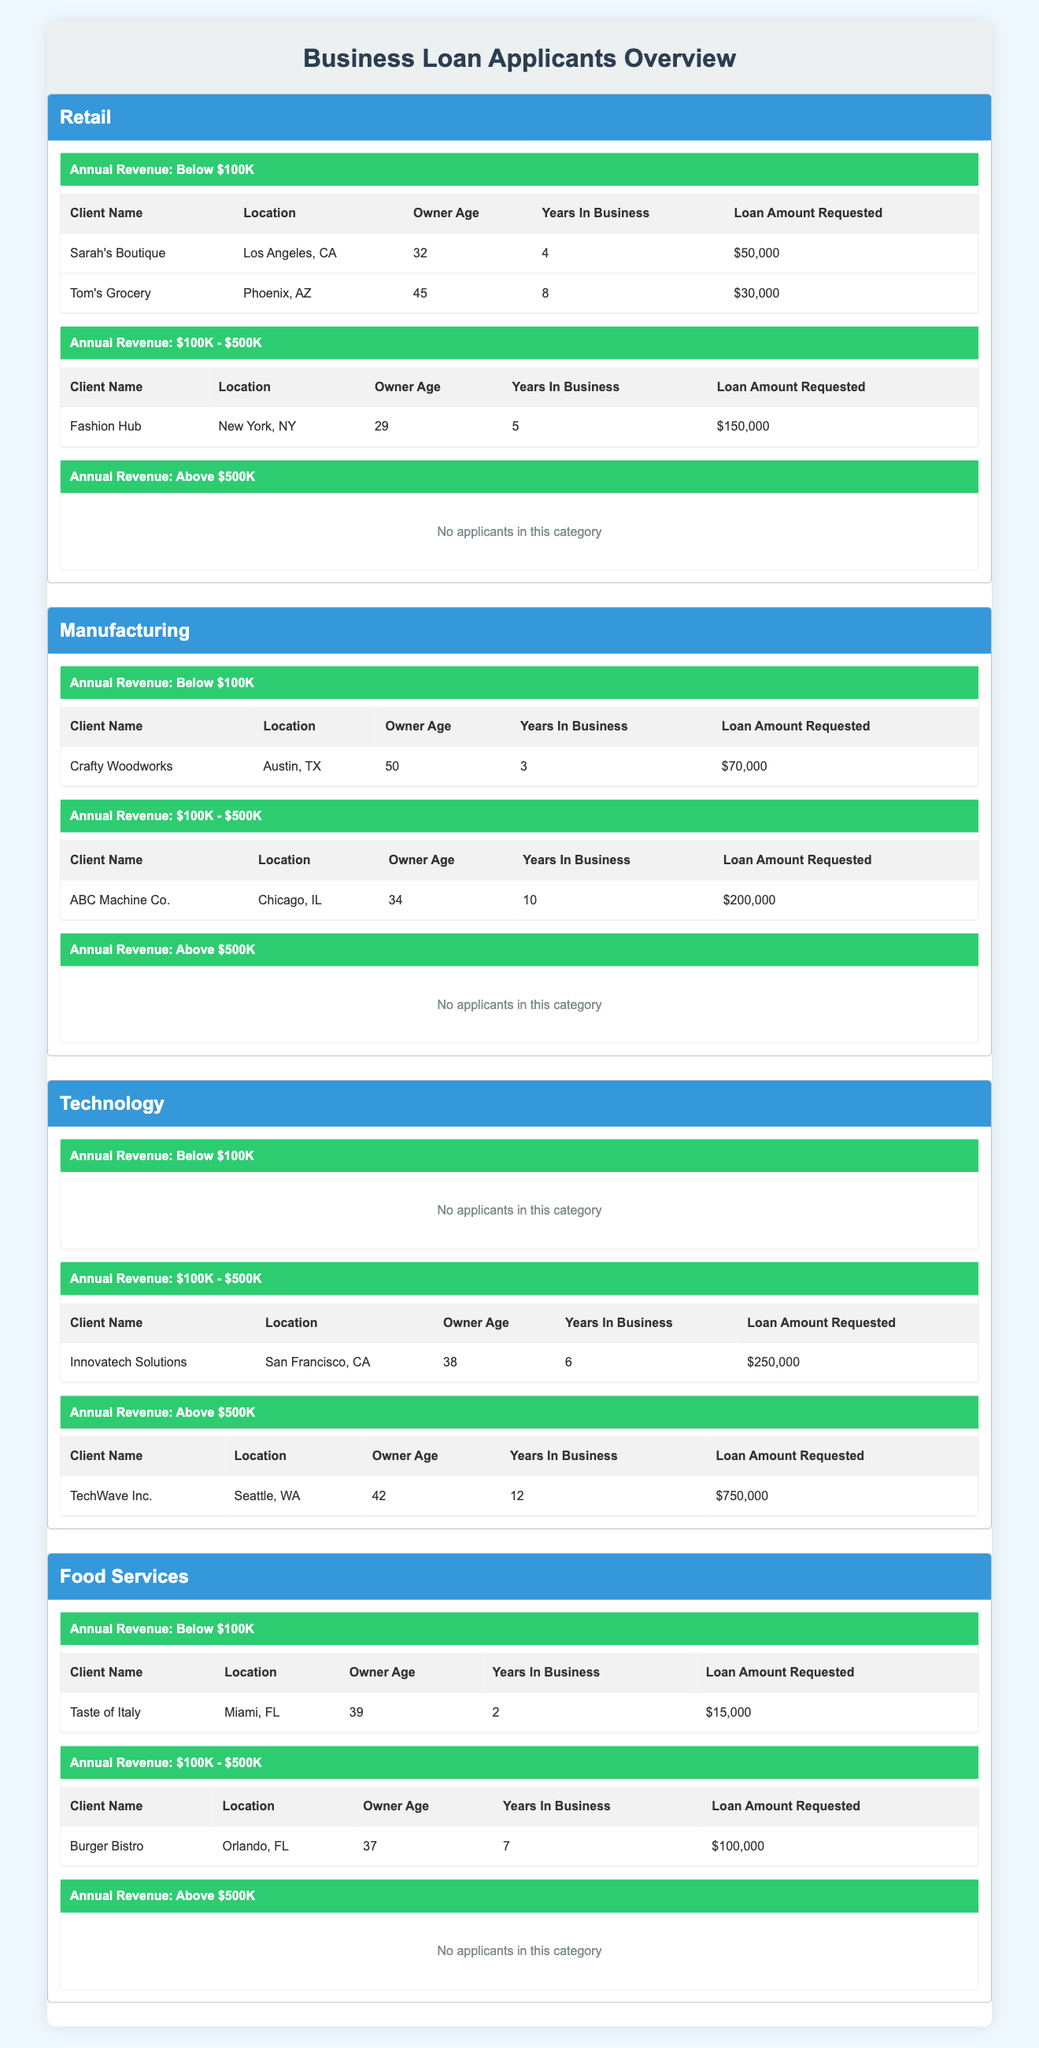What is the total loan amount requested by retail applicants? The retail applicants include Sarah's Boutique ($50,000), Tom's Grocery ($30,000), and Fashion Hub ($150,000). Adding these amounts together gives us $50,000 + $30,000 + $150,000 = $230,000.
Answer: 230000 Are there any technology businesses that requested a loan amount below $100K? According to the table, there are no technology businesses under the "Below $100K" category as it indicates "No applicants in this category."
Answer: No What is the average age of the owners for manufacturing businesses in the $100K - $500K revenue category? In the $100K - $500K revenue category for manufacturing, there is one applicant: ABC Machine Co. with an owner age of 34. Since there's only one data point, the average age is simply 34.
Answer: 34 How many years in business does the applicant with the lowest loan amount requested in food services have? The lowest loan amount requested in food services comes from Taste of Italy, which has been in business for 2 years.
Answer: 2 